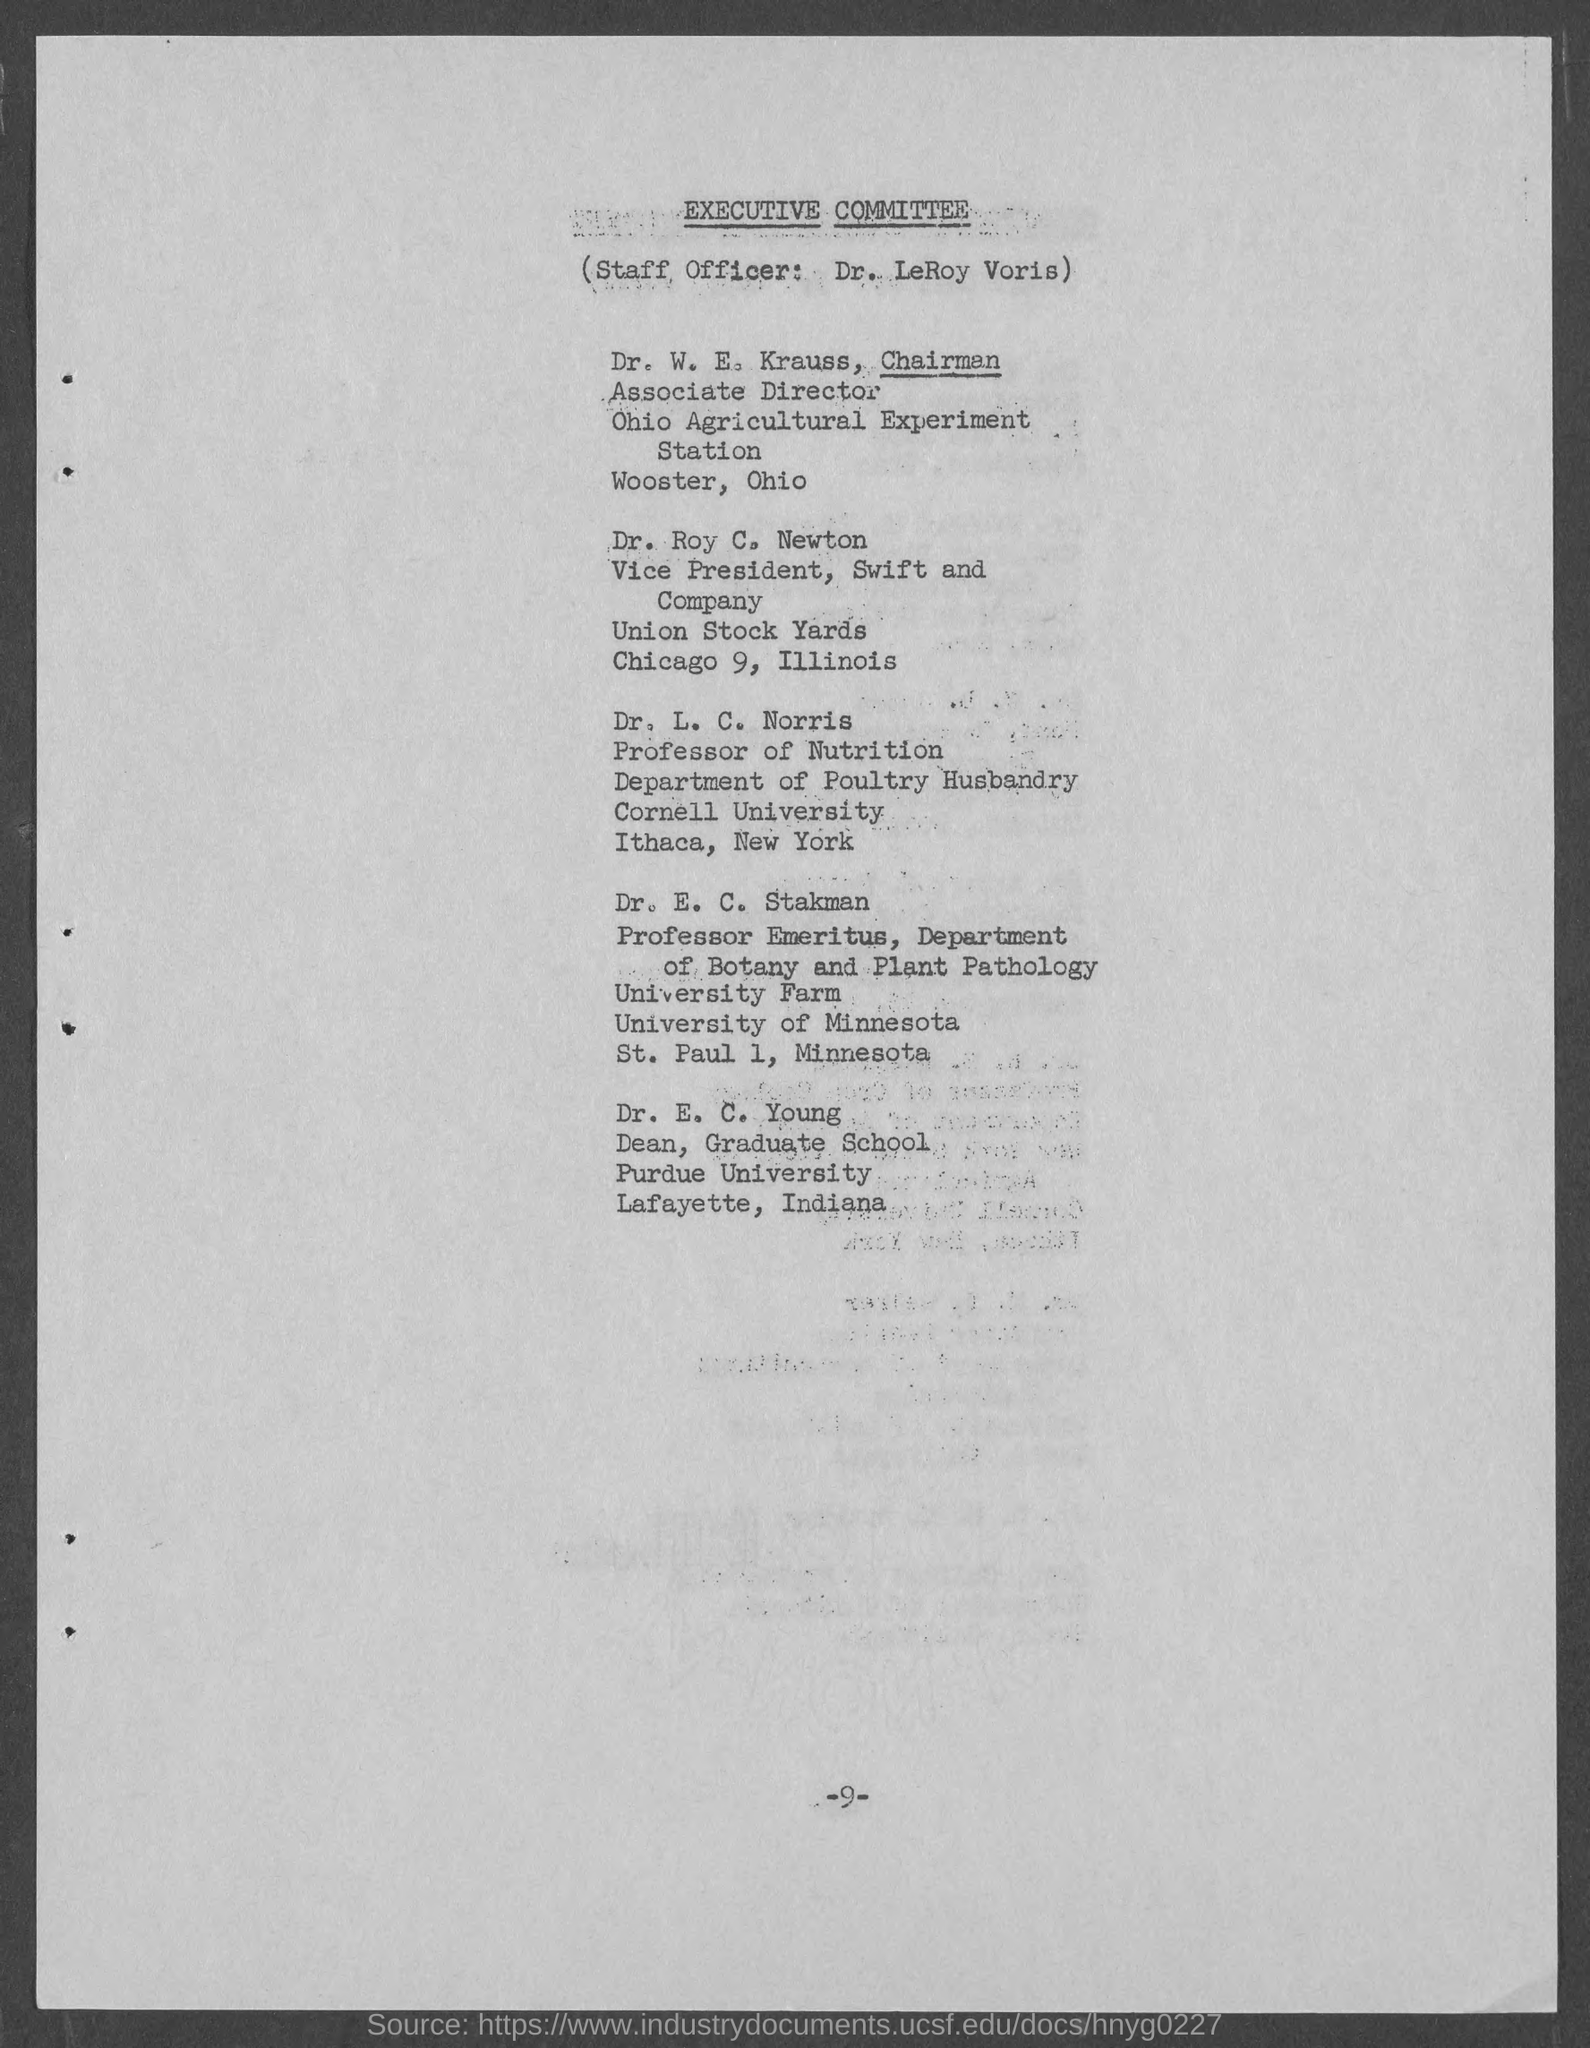Who is the staff officer?
Keep it short and to the point. Dr. LeRoy Voris. What is the name of committee?
Provide a short and direct response. Executive Committee. Who is the chairman and associate director of ohio agriculture experimentstation?
Keep it short and to the point. Dr. W. E. Krauss. Who is the vice-president of swift and company?
Offer a terse response. Dr. Roy C. Newton. 